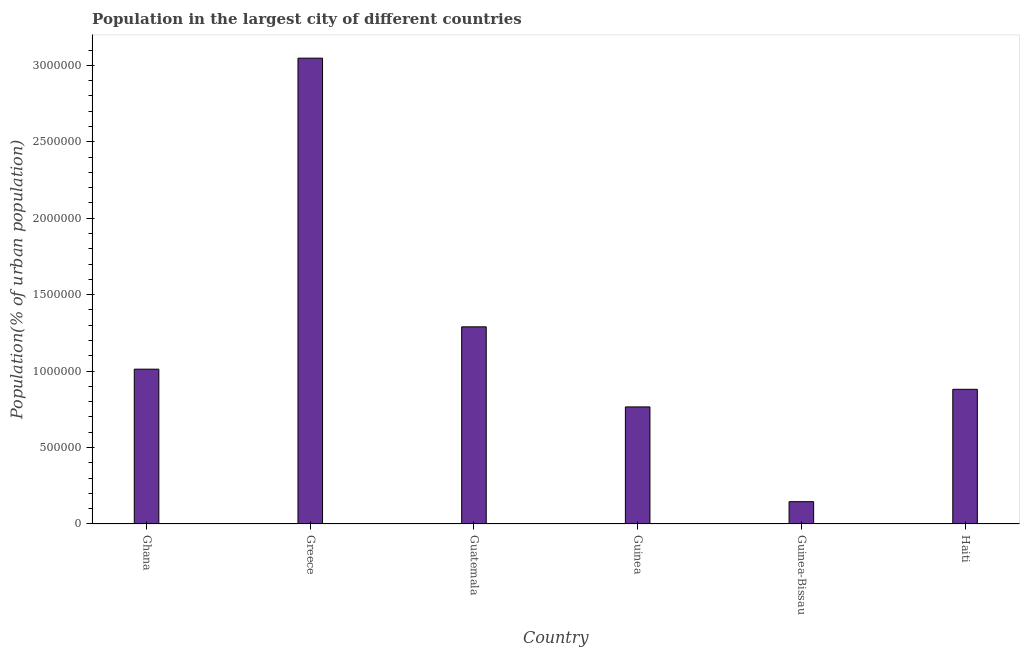Does the graph contain grids?
Offer a very short reply. No. What is the title of the graph?
Provide a short and direct response. Population in the largest city of different countries. What is the label or title of the X-axis?
Your answer should be compact. Country. What is the label or title of the Y-axis?
Give a very brief answer. Population(% of urban population). What is the population in largest city in Guinea?
Your answer should be compact. 7.66e+05. Across all countries, what is the maximum population in largest city?
Keep it short and to the point. 3.05e+06. Across all countries, what is the minimum population in largest city?
Your response must be concise. 1.46e+05. In which country was the population in largest city maximum?
Keep it short and to the point. Greece. In which country was the population in largest city minimum?
Make the answer very short. Guinea-Bissau. What is the sum of the population in largest city?
Provide a short and direct response. 7.14e+06. What is the difference between the population in largest city in Guatemala and Guinea-Bissau?
Your answer should be very brief. 1.14e+06. What is the average population in largest city per country?
Offer a terse response. 1.19e+06. What is the median population in largest city?
Your answer should be compact. 9.47e+05. In how many countries, is the population in largest city greater than 1500000 %?
Give a very brief answer. 1. What is the ratio of the population in largest city in Guinea-Bissau to that in Haiti?
Your answer should be very brief. 0.17. Is the population in largest city in Guinea less than that in Guinea-Bissau?
Your response must be concise. No. Is the difference between the population in largest city in Guatemala and Guinea-Bissau greater than the difference between any two countries?
Your answer should be very brief. No. What is the difference between the highest and the second highest population in largest city?
Offer a terse response. 1.76e+06. What is the difference between the highest and the lowest population in largest city?
Provide a short and direct response. 2.90e+06. How many bars are there?
Ensure brevity in your answer.  6. Are all the bars in the graph horizontal?
Offer a terse response. No. How many countries are there in the graph?
Make the answer very short. 6. What is the difference between two consecutive major ticks on the Y-axis?
Ensure brevity in your answer.  5.00e+05. What is the Population(% of urban population) of Ghana?
Your answer should be very brief. 1.01e+06. What is the Population(% of urban population) in Greece?
Offer a very short reply. 3.05e+06. What is the Population(% of urban population) in Guatemala?
Ensure brevity in your answer.  1.29e+06. What is the Population(% of urban population) in Guinea?
Your answer should be compact. 7.66e+05. What is the Population(% of urban population) in Guinea-Bissau?
Give a very brief answer. 1.46e+05. What is the Population(% of urban population) of Haiti?
Ensure brevity in your answer.  8.81e+05. What is the difference between the Population(% of urban population) in Ghana and Greece?
Your answer should be compact. -2.03e+06. What is the difference between the Population(% of urban population) in Ghana and Guatemala?
Your response must be concise. -2.77e+05. What is the difference between the Population(% of urban population) in Ghana and Guinea?
Keep it short and to the point. 2.47e+05. What is the difference between the Population(% of urban population) in Ghana and Guinea-Bissau?
Offer a terse response. 8.67e+05. What is the difference between the Population(% of urban population) in Ghana and Haiti?
Give a very brief answer. 1.32e+05. What is the difference between the Population(% of urban population) in Greece and Guatemala?
Offer a very short reply. 1.76e+06. What is the difference between the Population(% of urban population) in Greece and Guinea?
Make the answer very short. 2.28e+06. What is the difference between the Population(% of urban population) in Greece and Guinea-Bissau?
Provide a succinct answer. 2.90e+06. What is the difference between the Population(% of urban population) in Greece and Haiti?
Offer a very short reply. 2.17e+06. What is the difference between the Population(% of urban population) in Guatemala and Guinea?
Your response must be concise. 5.24e+05. What is the difference between the Population(% of urban population) in Guatemala and Guinea-Bissau?
Give a very brief answer. 1.14e+06. What is the difference between the Population(% of urban population) in Guatemala and Haiti?
Provide a short and direct response. 4.09e+05. What is the difference between the Population(% of urban population) in Guinea and Guinea-Bissau?
Keep it short and to the point. 6.20e+05. What is the difference between the Population(% of urban population) in Guinea and Haiti?
Make the answer very short. -1.15e+05. What is the difference between the Population(% of urban population) in Guinea-Bissau and Haiti?
Make the answer very short. -7.35e+05. What is the ratio of the Population(% of urban population) in Ghana to that in Greece?
Keep it short and to the point. 0.33. What is the ratio of the Population(% of urban population) in Ghana to that in Guatemala?
Your answer should be very brief. 0.79. What is the ratio of the Population(% of urban population) in Ghana to that in Guinea?
Offer a terse response. 1.32. What is the ratio of the Population(% of urban population) in Ghana to that in Guinea-Bissau?
Offer a very short reply. 6.94. What is the ratio of the Population(% of urban population) in Ghana to that in Haiti?
Offer a very short reply. 1.15. What is the ratio of the Population(% of urban population) in Greece to that in Guatemala?
Your response must be concise. 2.36. What is the ratio of the Population(% of urban population) in Greece to that in Guinea?
Provide a short and direct response. 3.98. What is the ratio of the Population(% of urban population) in Greece to that in Guinea-Bissau?
Ensure brevity in your answer.  20.88. What is the ratio of the Population(% of urban population) in Greece to that in Haiti?
Offer a terse response. 3.46. What is the ratio of the Population(% of urban population) in Guatemala to that in Guinea?
Your answer should be very brief. 1.68. What is the ratio of the Population(% of urban population) in Guatemala to that in Guinea-Bissau?
Keep it short and to the point. 8.84. What is the ratio of the Population(% of urban population) in Guatemala to that in Haiti?
Ensure brevity in your answer.  1.46. What is the ratio of the Population(% of urban population) in Guinea to that in Guinea-Bissau?
Provide a succinct answer. 5.25. What is the ratio of the Population(% of urban population) in Guinea to that in Haiti?
Your response must be concise. 0.87. What is the ratio of the Population(% of urban population) in Guinea-Bissau to that in Haiti?
Your answer should be very brief. 0.17. 